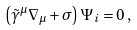Convert formula to latex. <formula><loc_0><loc_0><loc_500><loc_500>\left ( \tilde { \gamma } ^ { \mu } \nabla _ { \mu } + \sigma \right ) \Psi _ { i } = 0 \, ,</formula> 